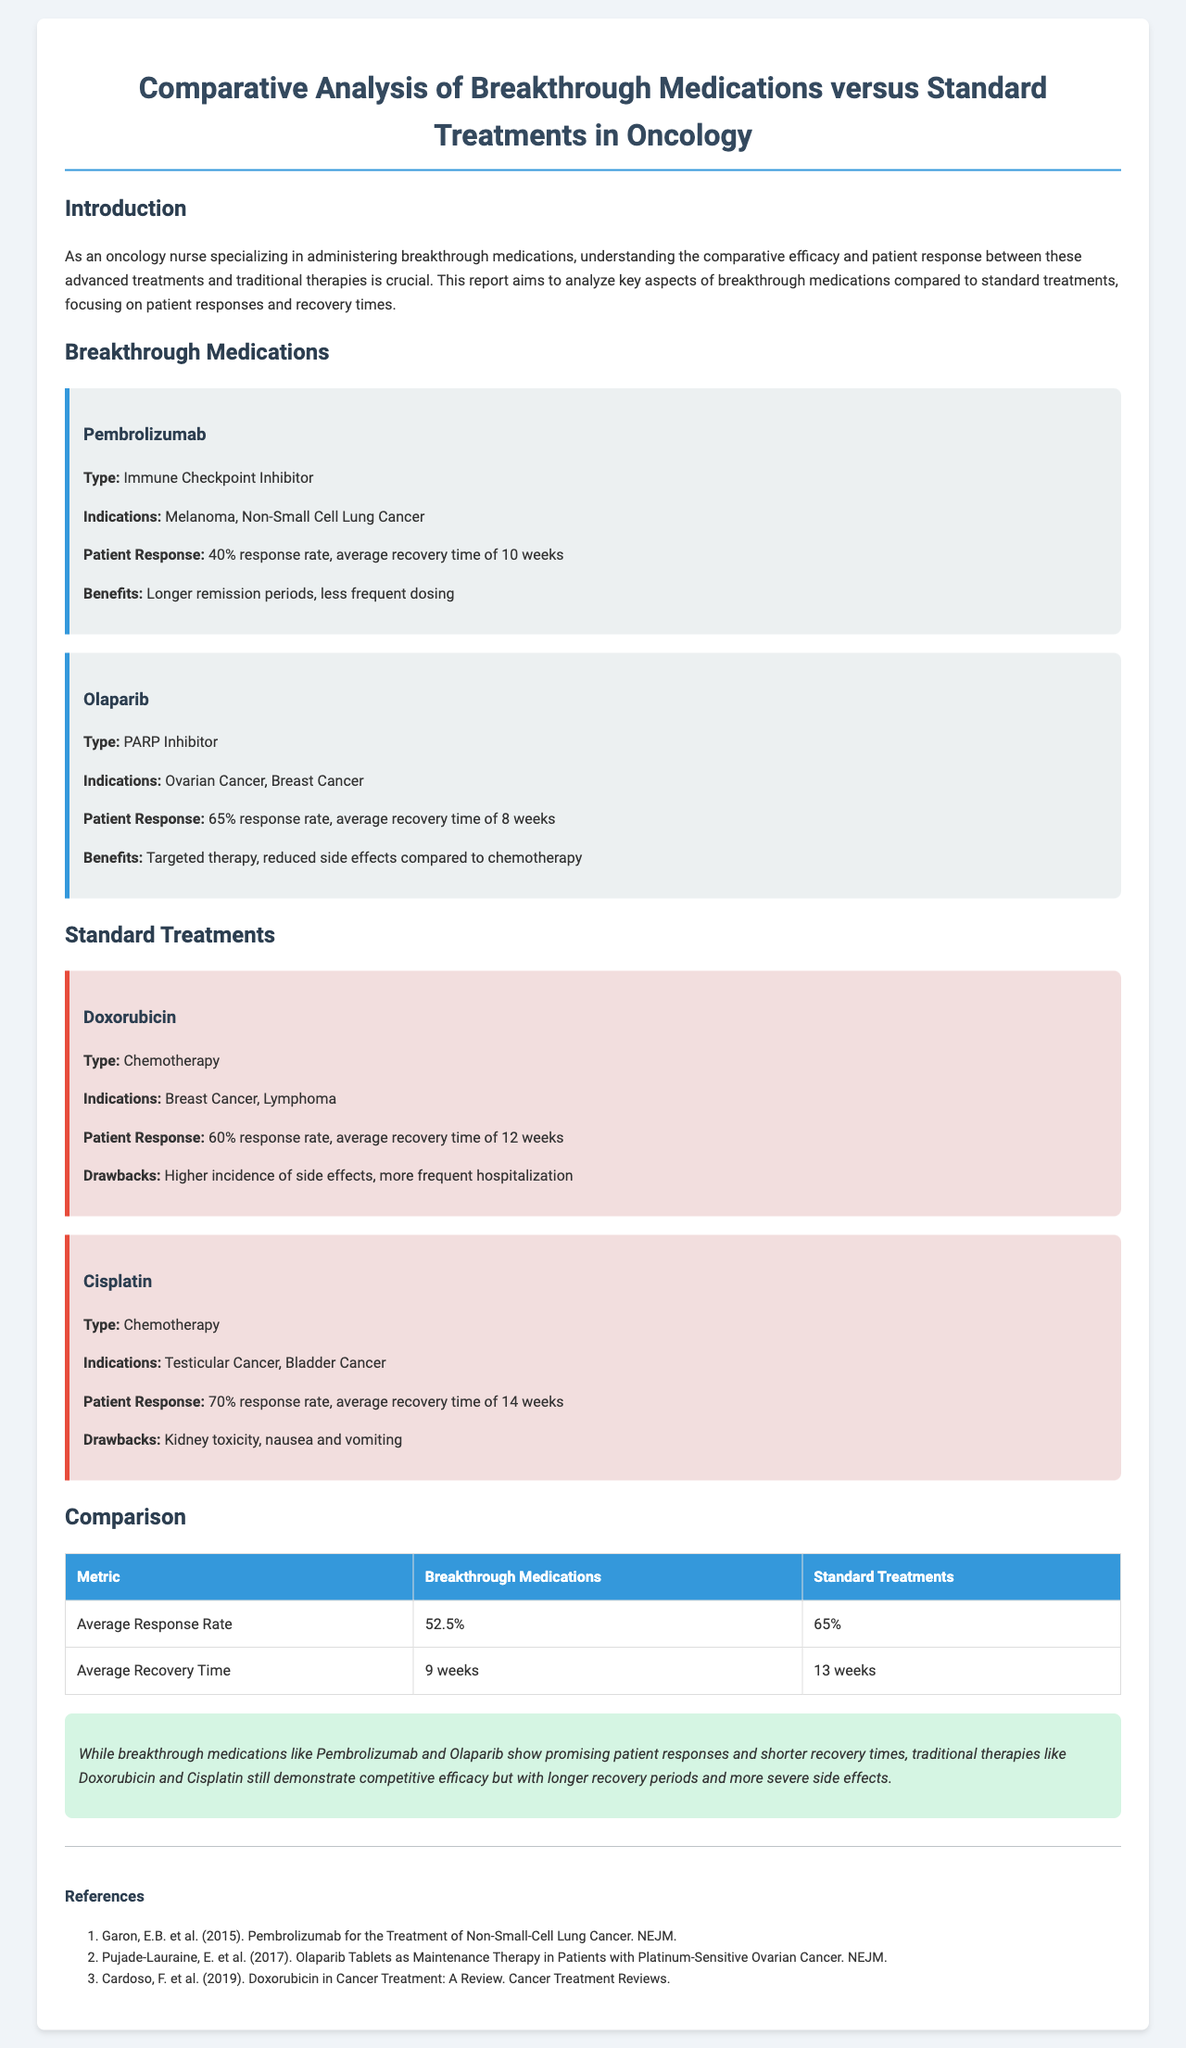What is the response rate for Pembrolizumab? The response rate for Pembrolizumab is stated within the document as 40%.
Answer: 40% What is the average recovery time for Olaparib? The average recovery time for Olaparib is mentioned in the document as 8 weeks.
Answer: 8 weeks What type of medication is Doxorubicin? Doxorubicin is categorized as chemotherapy, according to the document.
Answer: Chemotherapy What is the average response rate for standard treatments? The document specifies the average response rate for standard treatments as 65%.
Answer: 65% How many weeks is the average recovery time for breakthrough medications? The document summarizes that the average recovery time for breakthrough medications is 9 weeks.
Answer: 9 weeks Which breakthrough medication has a higher response rate, Pembrolizumab or Olaparib? The response rates are compared in the document, indicating Olaparib at 65% has a higher rate than Pembrolizumab at 40%.
Answer: Olaparib What is a major drawback of Cisplatin? The document mentions kidney toxicity as a significant drawback of Cisplatin.
Answer: Kidney toxicity In what year was the study on Pembrolizumab published? The document references a study published in 2015 regarding Pembrolizumab.
Answer: 2015 What type of report is this document presenting? The document presents a comparative analysis focused on oncology medications.
Answer: Comparative analysis 